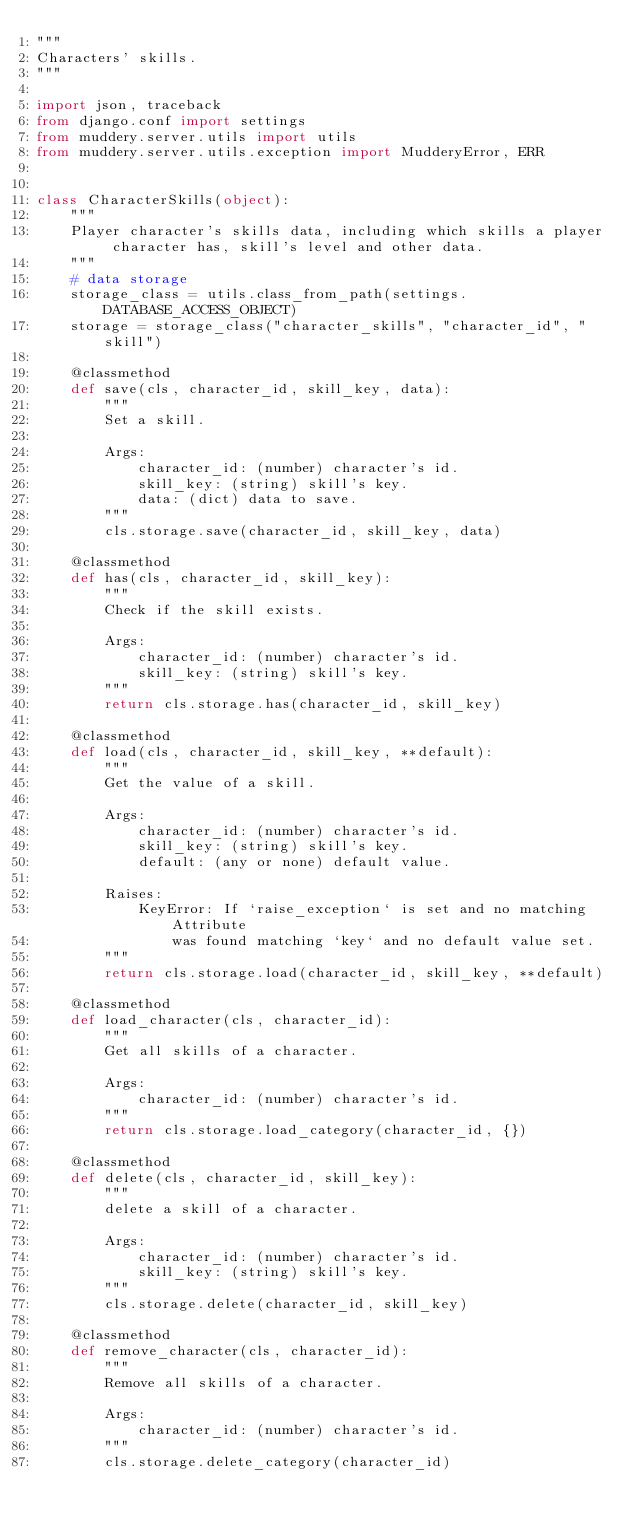<code> <loc_0><loc_0><loc_500><loc_500><_Python_>"""
Characters' skills.
"""

import json, traceback
from django.conf import settings
from muddery.server.utils import utils
from muddery.server.utils.exception import MudderyError, ERR


class CharacterSkills(object):
    """
    Player character's skills data, including which skills a player character has, skill's level and other data.
    """
    # data storage
    storage_class = utils.class_from_path(settings.DATABASE_ACCESS_OBJECT)
    storage = storage_class("character_skills", "character_id", "skill")

    @classmethod
    def save(cls, character_id, skill_key, data):
        """
        Set a skill.

        Args:
            character_id: (number) character's id.
            skill_key: (string) skill's key.
            data: (dict) data to save.
        """
        cls.storage.save(character_id, skill_key, data)

    @classmethod
    def has(cls, character_id, skill_key):
        """
        Check if the skill exists.

        Args:
            character_id: (number) character's id.
            skill_key: (string) skill's key.
        """
        return cls.storage.has(character_id, skill_key)

    @classmethod
    def load(cls, character_id, skill_key, **default):
        """
        Get the value of a skill.

        Args:
            character_id: (number) character's id.
            skill_key: (string) skill's key.
            default: (any or none) default value.

        Raises:
            KeyError: If `raise_exception` is set and no matching Attribute
                was found matching `key` and no default value set.
        """
        return cls.storage.load(character_id, skill_key, **default)

    @classmethod
    def load_character(cls, character_id):
        """
        Get all skills of a character.

        Args:
            character_id: (number) character's id.
        """
        return cls.storage.load_category(character_id, {})

    @classmethod
    def delete(cls, character_id, skill_key):
        """
        delete a skill of a character.

        Args:
            character_id: (number) character's id.
            skill_key: (string) skill's key.
        """
        cls.storage.delete(character_id, skill_key)

    @classmethod
    def remove_character(cls, character_id):
        """
        Remove all skills of a character.

        Args:
            character_id: (number) character's id.
        """
        cls.storage.delete_category(character_id)
</code> 